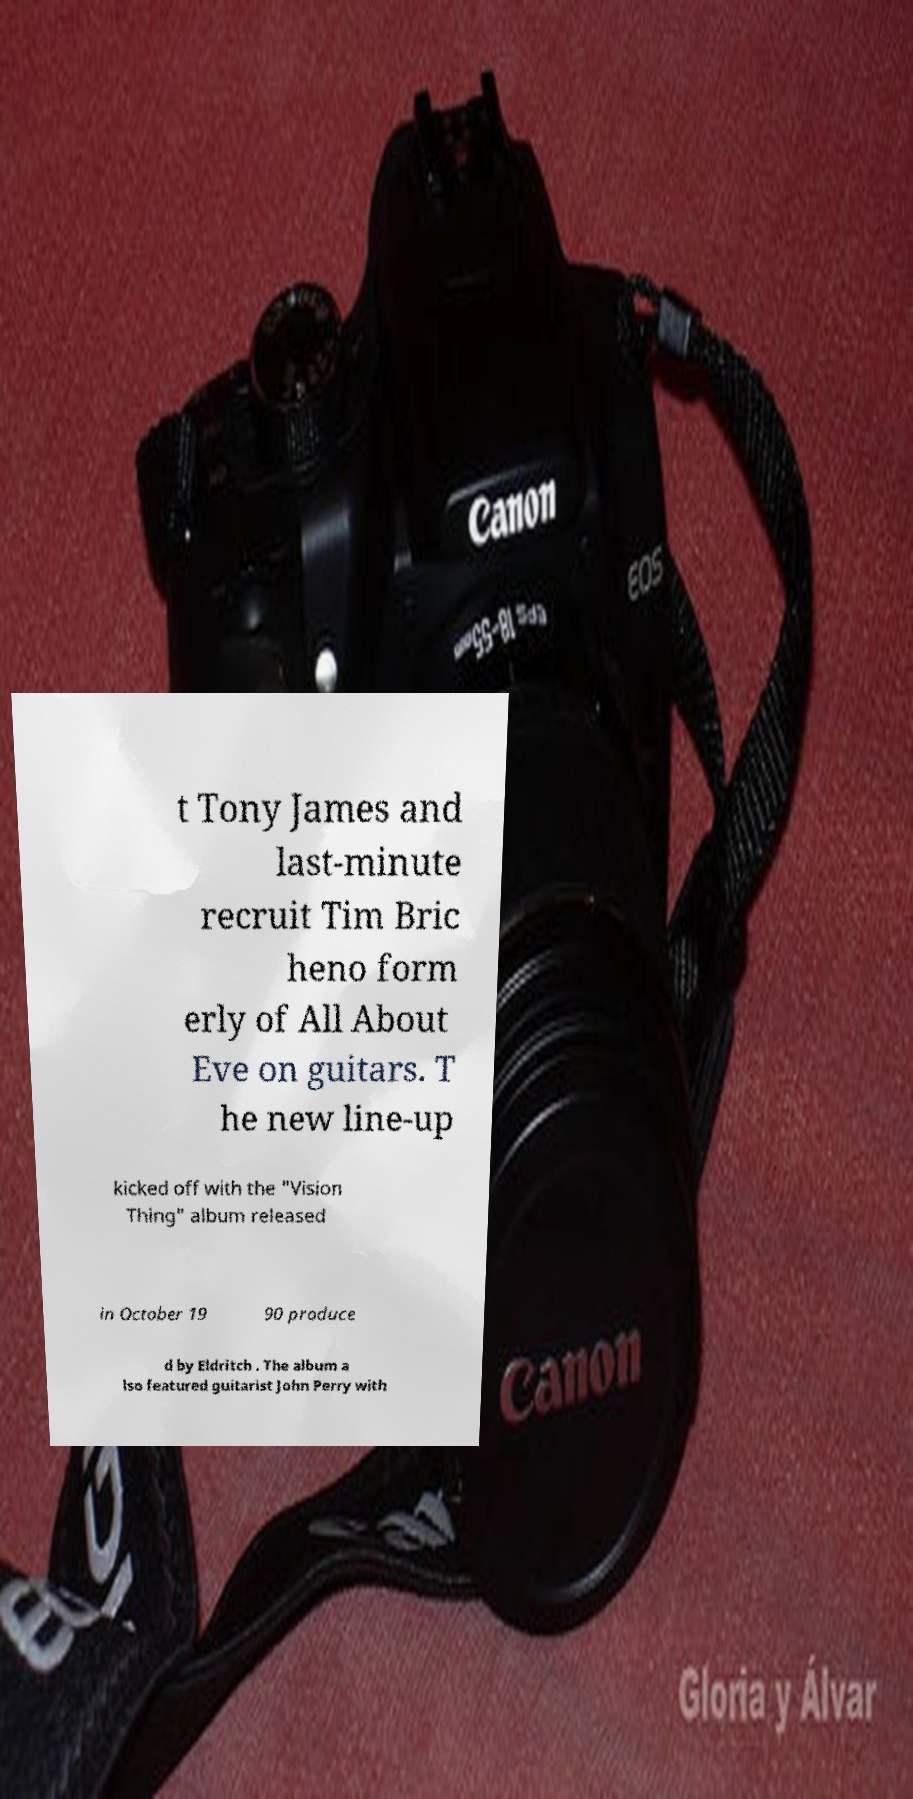For documentation purposes, I need the text within this image transcribed. Could you provide that? t Tony James and last-minute recruit Tim Bric heno form erly of All About Eve on guitars. T he new line-up kicked off with the "Vision Thing" album released in October 19 90 produce d by Eldritch . The album a lso featured guitarist John Perry with 